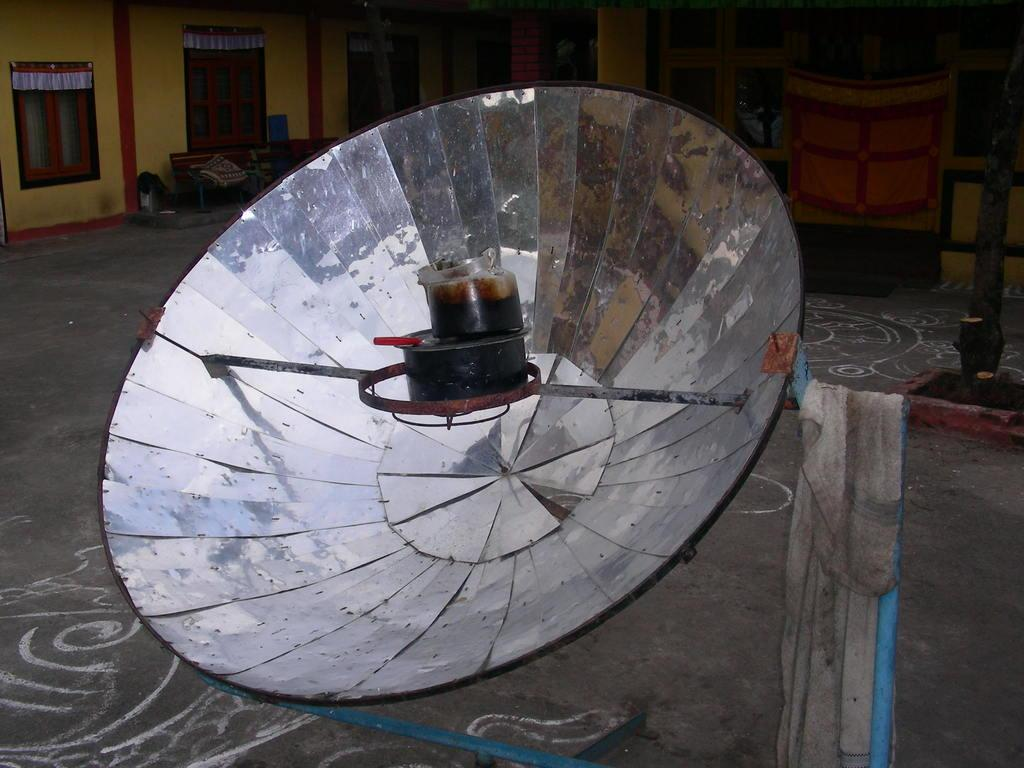What is the tall, thin object in the image? There is an antenna in the image. Where is the antenna attached? The antenna is fixed to a road. What is at the bottom of the image? There is a floor at the bottom of the image. What can be seen in the background of the image? There is a house in the background of the image. What features does the house have? The house has doors and windows. What degree does the antenna have in the image? The antenna does not have a degree; it is an inanimate object. Is there a bomb visible in the image? No, there is no bomb present in the image. 